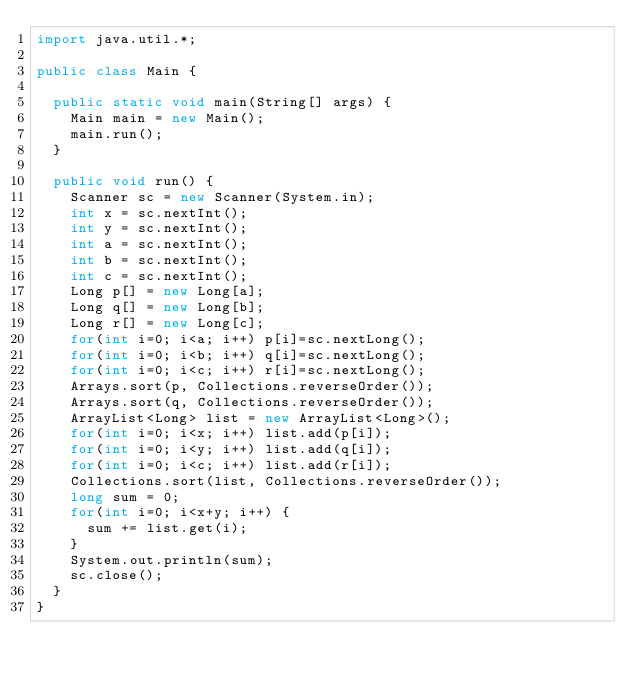Convert code to text. <code><loc_0><loc_0><loc_500><loc_500><_Java_>import java.util.*;

public class Main {

	public static void main(String[] args) {
		Main main = new Main();
		main.run();
	}

	public void run() {
		Scanner sc = new Scanner(System.in);
		int x = sc.nextInt();
		int y = sc.nextInt();
		int a = sc.nextInt();
		int b = sc.nextInt();
		int c = sc.nextInt();
		Long p[] = new Long[a];
		Long q[] = new Long[b];
		Long r[] = new Long[c];
		for(int i=0; i<a; i++) p[i]=sc.nextLong();
		for(int i=0; i<b; i++) q[i]=sc.nextLong();
		for(int i=0; i<c; i++) r[i]=sc.nextLong();
		Arrays.sort(p, Collections.reverseOrder());
		Arrays.sort(q, Collections.reverseOrder());
		ArrayList<Long> list = new ArrayList<Long>();
		for(int i=0; i<x; i++) list.add(p[i]);
		for(int i=0; i<y; i++) list.add(q[i]);
		for(int i=0; i<c; i++) list.add(r[i]);
		Collections.sort(list, Collections.reverseOrder());
		long sum = 0;
		for(int i=0; i<x+y; i++) {
			sum += list.get(i);
		}
		System.out.println(sum);
		sc.close();
	}
}
</code> 